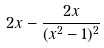Convert formula to latex. <formula><loc_0><loc_0><loc_500><loc_500>2 x - \frac { 2 x } { ( x ^ { 2 } - 1 ) ^ { 2 } }</formula> 